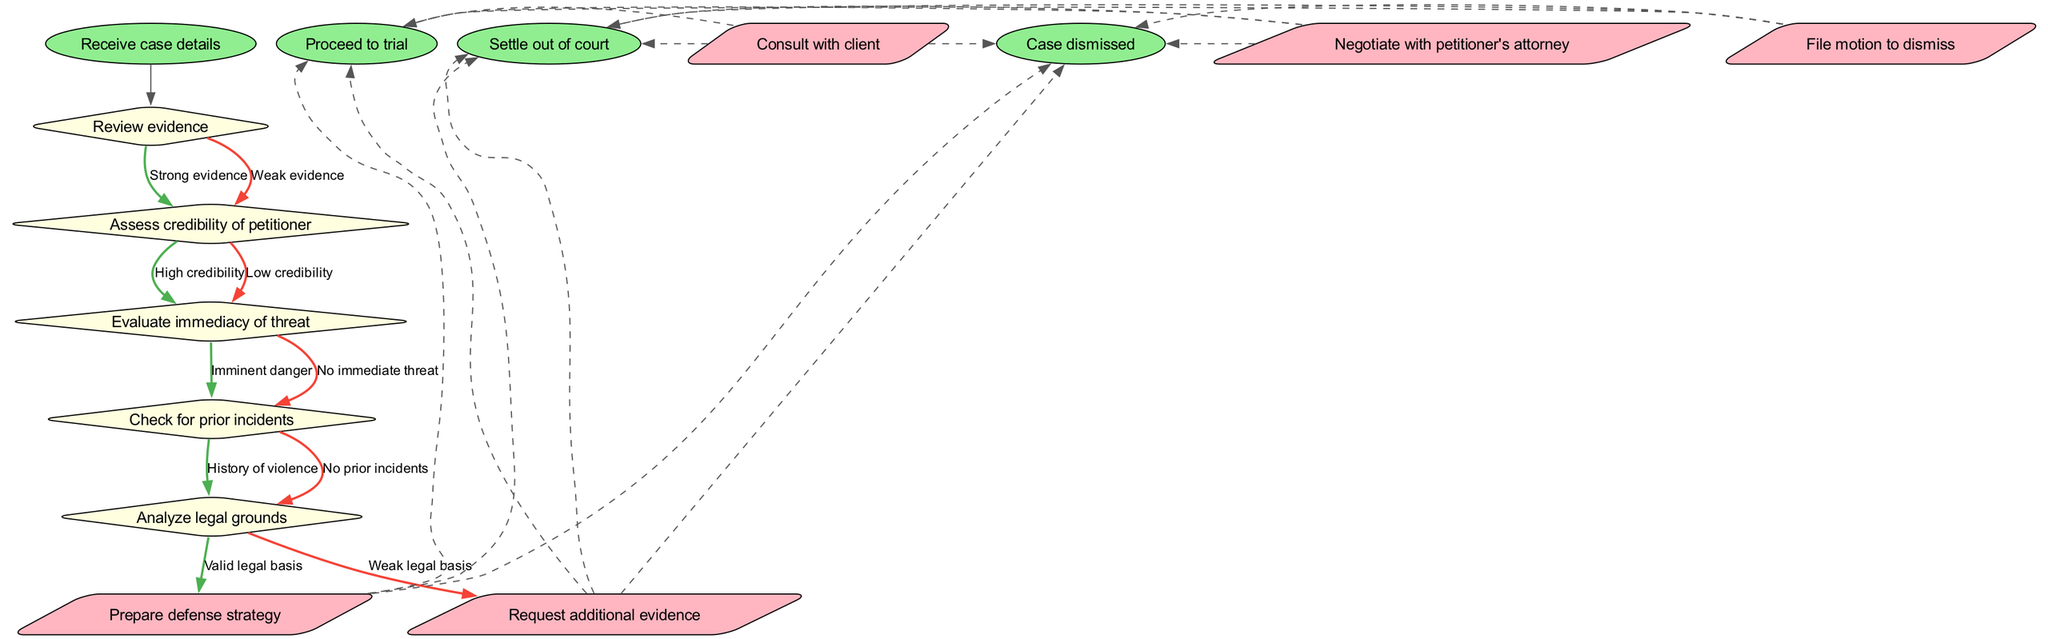What is the first node in the flowchart? The first node is indicated directly after the start node, which is "Review evidence." This is the process that initiates the decision-making regarding the protection order.
Answer: Review evidence How many decision nodes are present in the diagram? The diagram contains five decision nodes, as listed under the 'decisions' section, each one addressing different aspects of the case assessment.
Answer: 5 What is the last action node before reaching the end nodes? The last action node is "File motion to dismiss." This is the final step in the actions taken before determining the outcome of the case.
Answer: File motion to dismiss If there is "Weak evidence," what is the next step in the flowchart? Following "Weak evidence," the flowchart will transition to "Assess credibility of petitioner." This is the next logical step in the assessment process.
Answer: Assess credibility of petitioner What happens if there is "No prior incidents"? If there are "No prior incidents," the next decision node in the flowchart will be "Analyze legal grounds." This indicates a flow towards evaluating the legal foundation of the case.
Answer: Analyze legal grounds Is "Proceed to trial" directly connected to an action node? Yes, "Proceed to trial" is one of the possible outcomes that connects directly from the action nodes through dashed lines, indicating a path to finalize the case outcome.
Answer: Yes How many edges connect from the "Evaluate immediacy of threat" node? There are two edges connecting from "Evaluate immediacy of threat," leading to "Imminent danger" and "No immediate threat." Each edge represents a possible assessment of the threat level.
Answer: 2 If the petitioner has "High credibility," which action can be taken next? If "High credibility" is assessed, the logical next action could be to "Prepare defense strategy,” leading to proactive measures in handling the case based on the credibility factor.
Answer: Prepare defense strategy What are the end outcomes available in the flowchart? The end outcomes listed in the diagram are "Proceed to trial,” "Settle out of court,” and "Case dismissed." Each of these represents a different resolution to the case.
Answer: Proceed to trial, Settle out of court, Case dismissed 